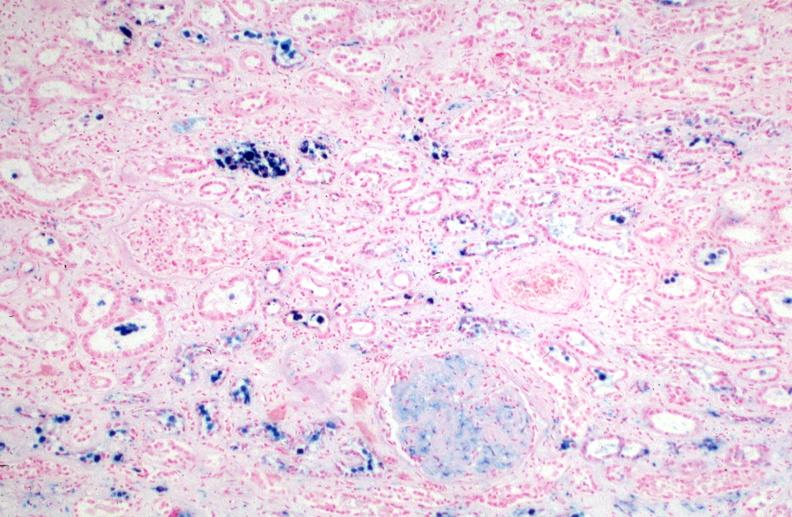does this image show kidney, chronic sickle cell disease?
Answer the question using a single word or phrase. Yes 